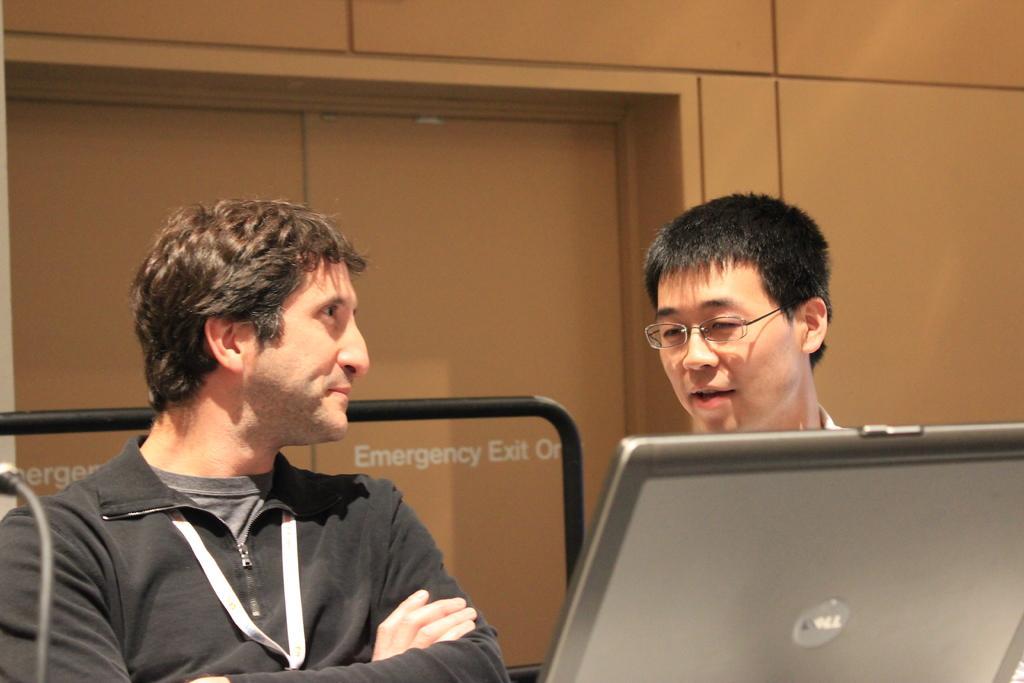Could you give a brief overview of what you see in this image? In this image we can see two persons. We can also see a laptop. In the background we can see the black color rod, wall and also the door with the text. 